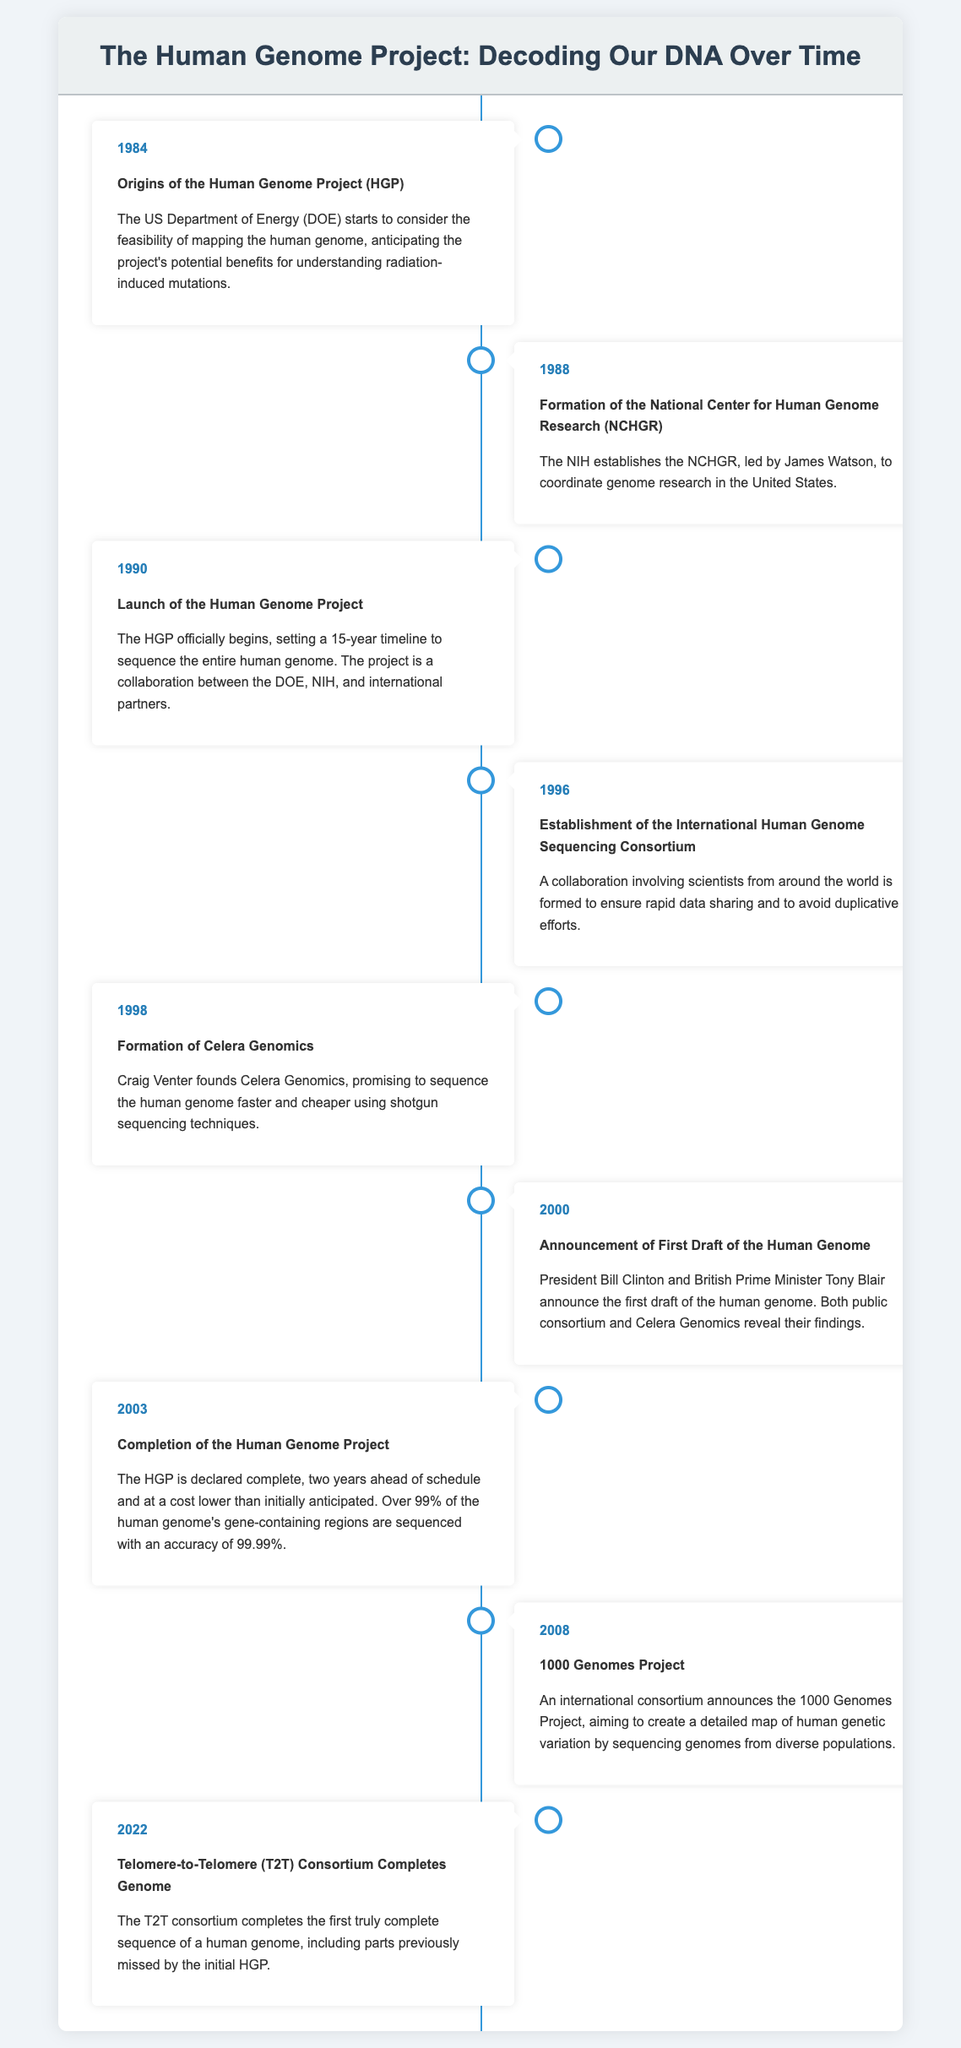What year did the Human Genome Project officially begin? The document states that the Human Genome Project officially begins in 1990.
Answer: 1990 Who founded Celera Genomics? According to the document, Craig Venter founded Celera Genomics in 1998.
Answer: Craig Venter What was the first significant milestone announced in 2000? The document indicates that the first draft of the human genome was announced in 2000.
Answer: First Draft of the Human Genome Which project aimed to create a detailed map of human genetic variation? The document mentions that the 1000 Genomes Project aimed to create a detailed map of human genetic variation launched in 2008.
Answer: 1000 Genomes Project How many years ahead of schedule was the Human Genome Project completed? The document notes that the HGP was completed two years ahead of schedule in 2003.
Answer: Two years What percentage accuracy was achieved in sequencing the gene-containing regions? The document states that the sequencing of gene-containing regions achieved an accuracy of 99.99%.
Answer: 99.99% What consortium completed the first truly complete sequence of a human genome? According to the document, the Telomere-to-Telomere (T2T) Consortium completed the first truly complete sequence in 2022.
Answer: Telomere-to-Telomere (T2T) Consortium What was the primary benefit anticipated from the Human Genome Project by the US Department of Energy? The document mentions that the US Department of Energy anticipated benefits for understanding radiation-induced mutations.
Answer: Understanding radiation-induced mutations In which year was the National Center for Human Genome Research established? The establishment of the National Center for Human Genome Research occurred in 1988.
Answer: 1988 